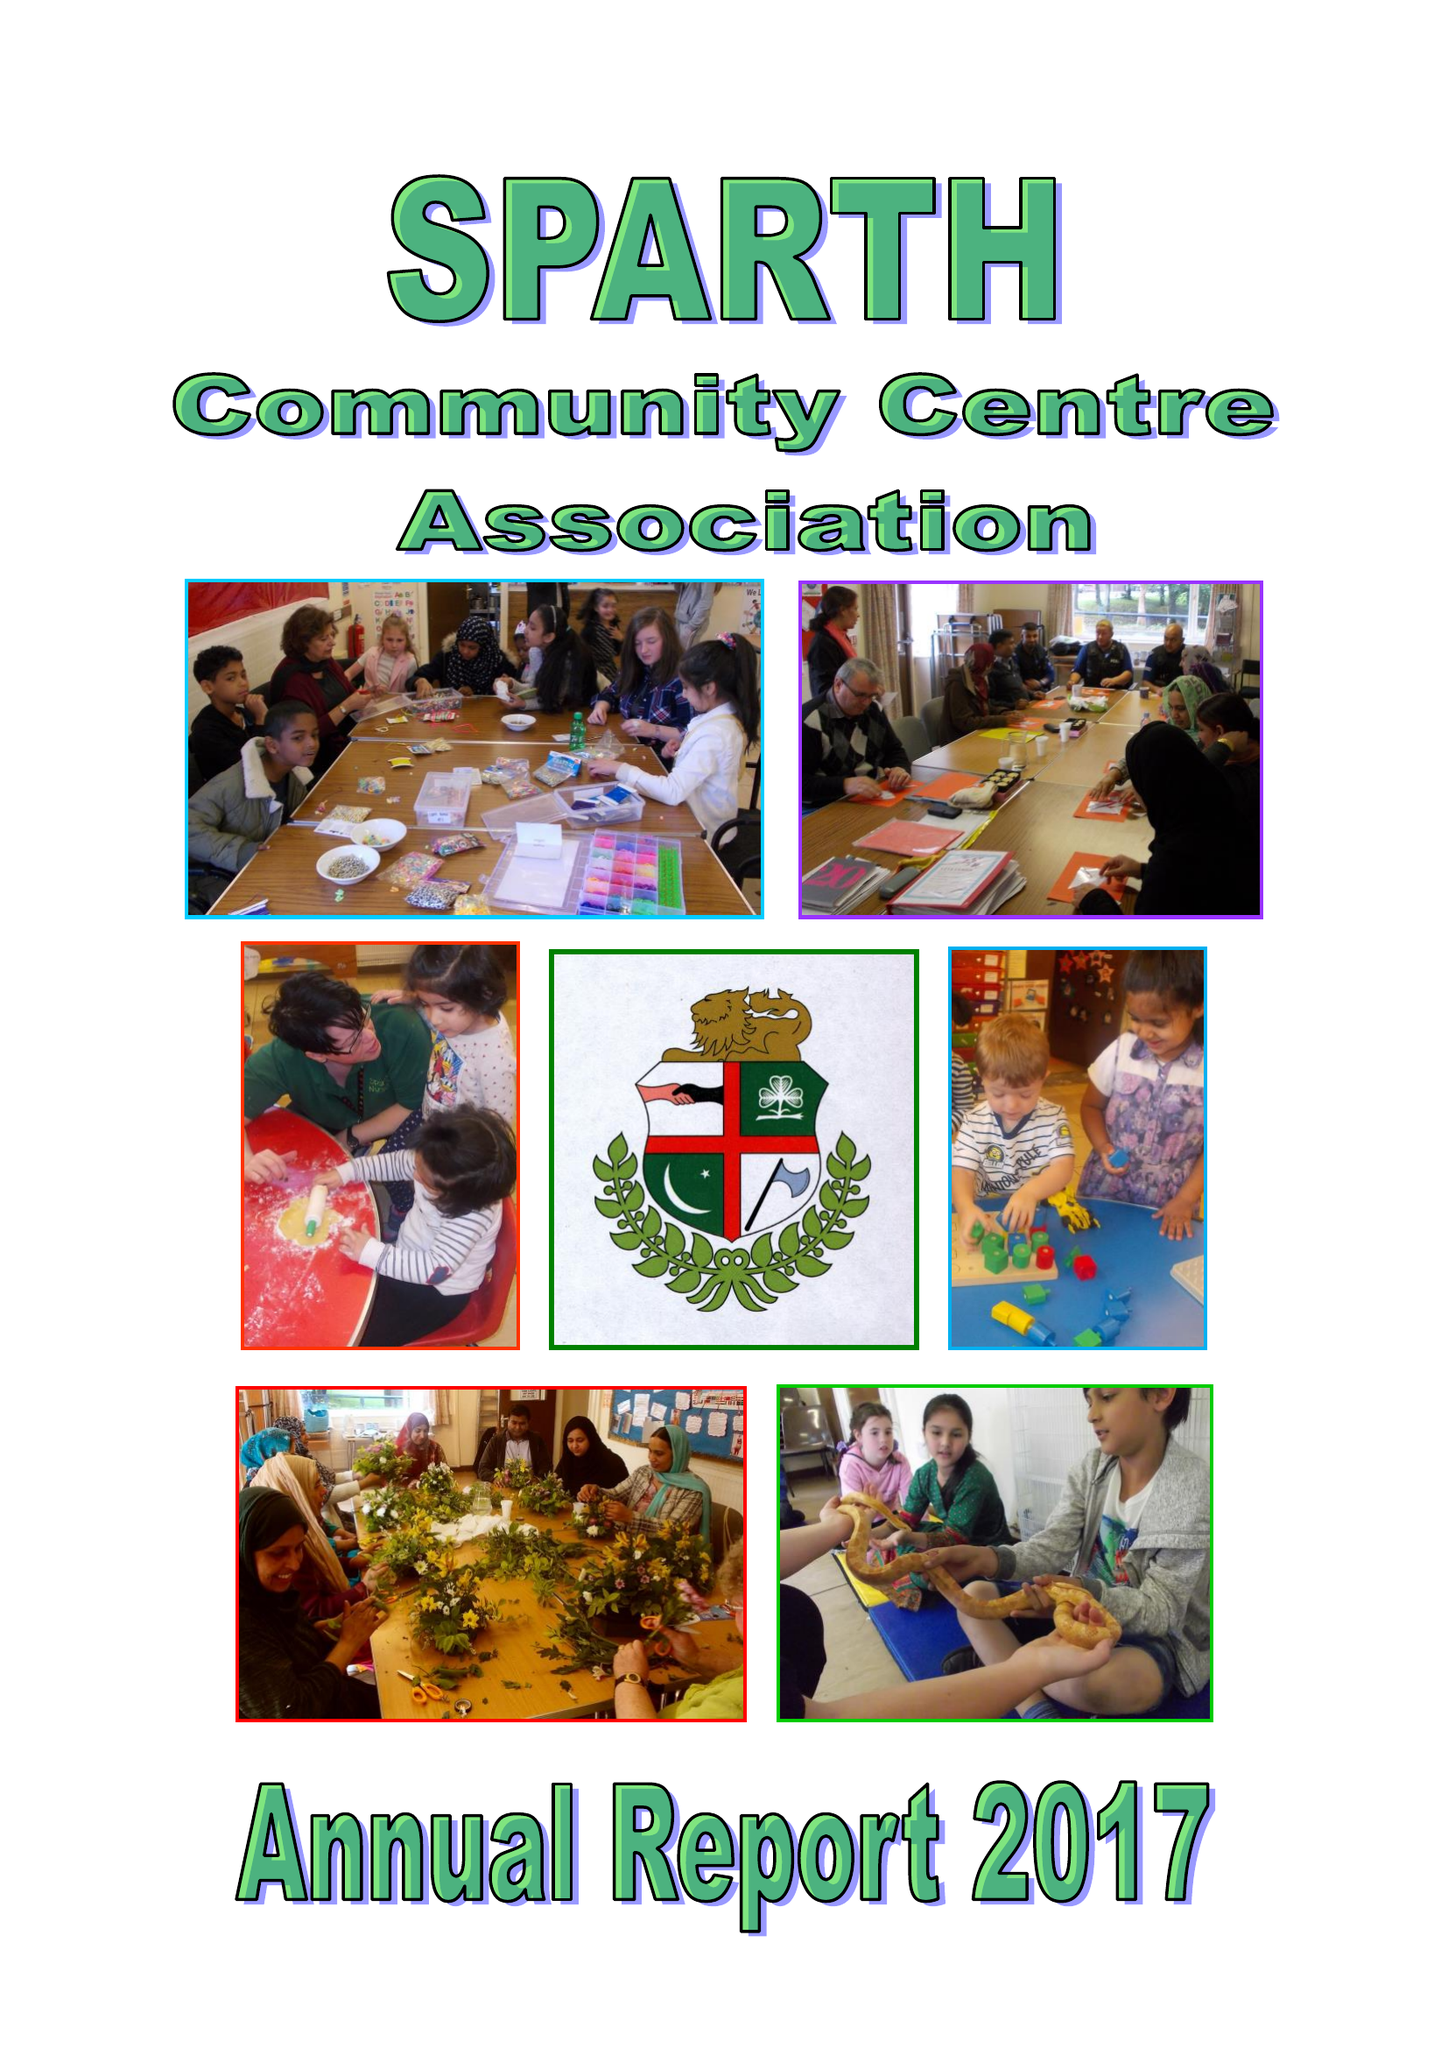What is the value for the report_date?
Answer the question using a single word or phrase. 2017-03-31 